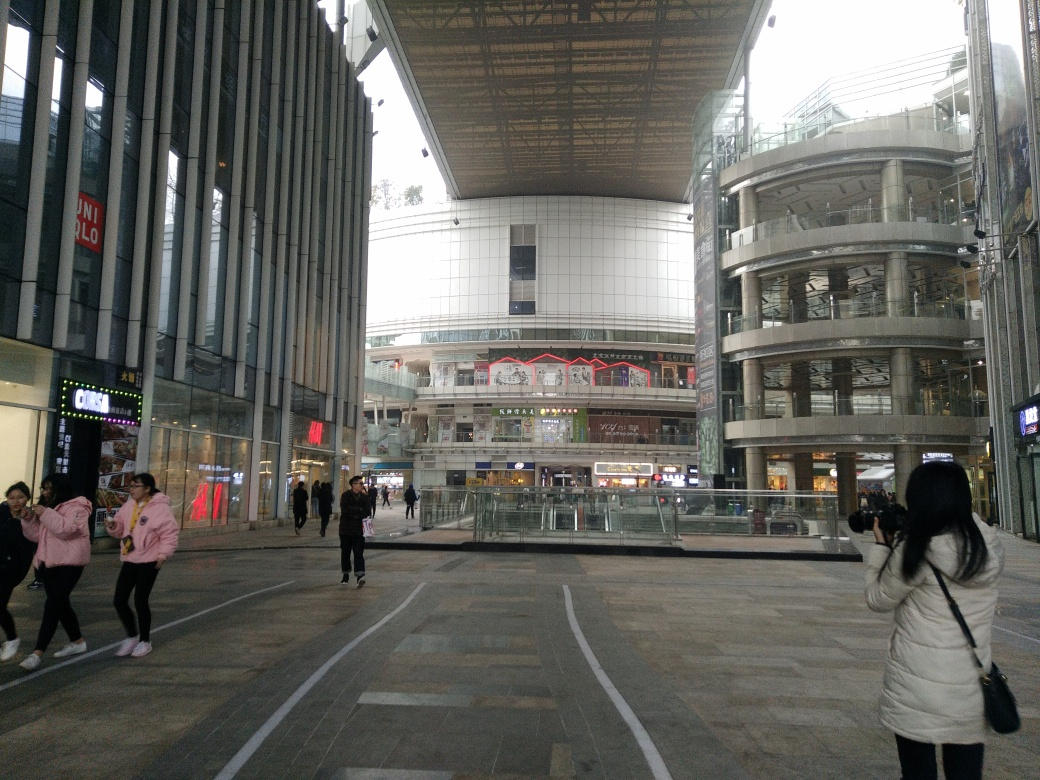What weather conditions are implied by the clothing of the people? The people in the image are wearing jackets and long sleeves, suggesting that the weather is likely cool or cold. The attire indicates it might be fall or winter season, or the location could have a generally cool climate. 